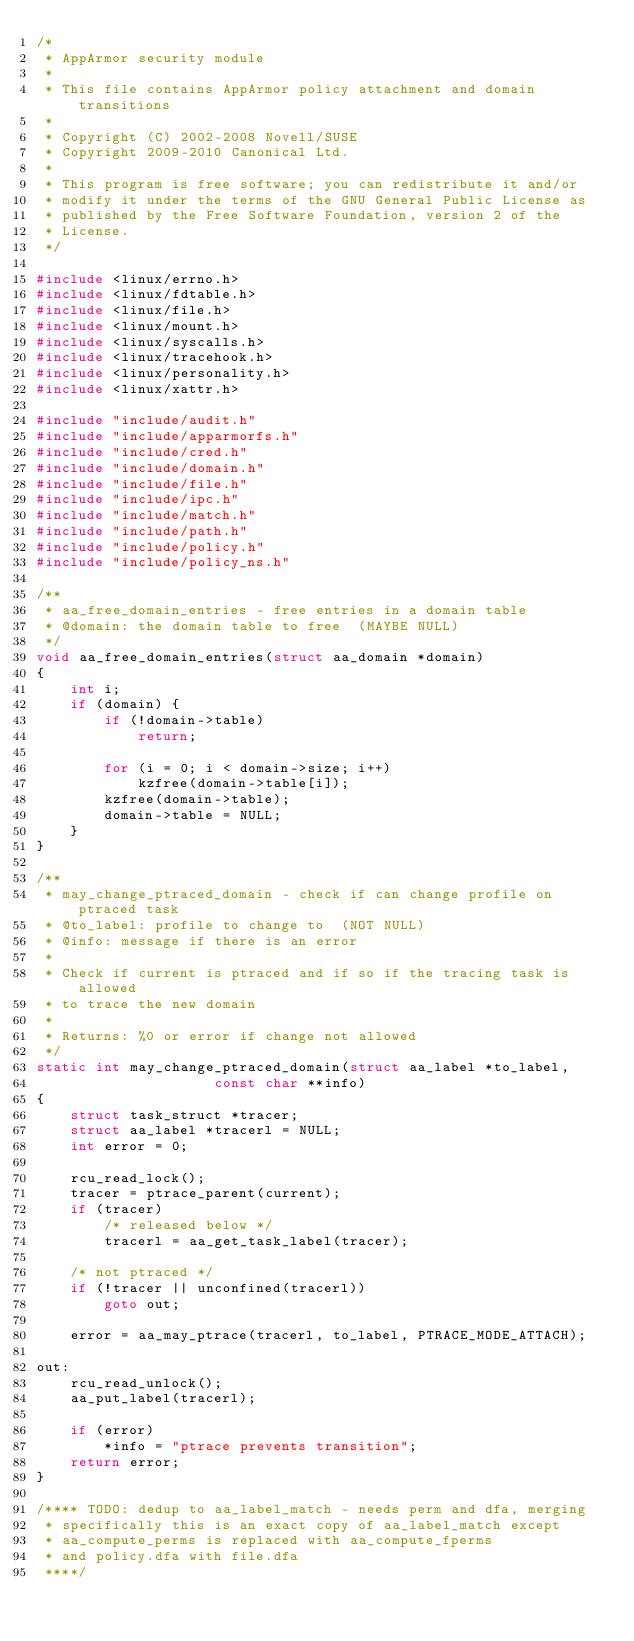<code> <loc_0><loc_0><loc_500><loc_500><_C_>/*
 * AppArmor security module
 *
 * This file contains AppArmor policy attachment and domain transitions
 *
 * Copyright (C) 2002-2008 Novell/SUSE
 * Copyright 2009-2010 Canonical Ltd.
 *
 * This program is free software; you can redistribute it and/or
 * modify it under the terms of the GNU General Public License as
 * published by the Free Software Foundation, version 2 of the
 * License.
 */

#include <linux/errno.h>
#include <linux/fdtable.h>
#include <linux/file.h>
#include <linux/mount.h>
#include <linux/syscalls.h>
#include <linux/tracehook.h>
#include <linux/personality.h>
#include <linux/xattr.h>

#include "include/audit.h"
#include "include/apparmorfs.h"
#include "include/cred.h"
#include "include/domain.h"
#include "include/file.h"
#include "include/ipc.h"
#include "include/match.h"
#include "include/path.h"
#include "include/policy.h"
#include "include/policy_ns.h"

/**
 * aa_free_domain_entries - free entries in a domain table
 * @domain: the domain table to free  (MAYBE NULL)
 */
void aa_free_domain_entries(struct aa_domain *domain)
{
	int i;
	if (domain) {
		if (!domain->table)
			return;

		for (i = 0; i < domain->size; i++)
			kzfree(domain->table[i]);
		kzfree(domain->table);
		domain->table = NULL;
	}
}

/**
 * may_change_ptraced_domain - check if can change profile on ptraced task
 * @to_label: profile to change to  (NOT NULL)
 * @info: message if there is an error
 *
 * Check if current is ptraced and if so if the tracing task is allowed
 * to trace the new domain
 *
 * Returns: %0 or error if change not allowed
 */
static int may_change_ptraced_domain(struct aa_label *to_label,
				     const char **info)
{
	struct task_struct *tracer;
	struct aa_label *tracerl = NULL;
	int error = 0;

	rcu_read_lock();
	tracer = ptrace_parent(current);
	if (tracer)
		/* released below */
		tracerl = aa_get_task_label(tracer);

	/* not ptraced */
	if (!tracer || unconfined(tracerl))
		goto out;

	error = aa_may_ptrace(tracerl, to_label, PTRACE_MODE_ATTACH);

out:
	rcu_read_unlock();
	aa_put_label(tracerl);

	if (error)
		*info = "ptrace prevents transition";
	return error;
}

/**** TODO: dedup to aa_label_match - needs perm and dfa, merging
 * specifically this is an exact copy of aa_label_match except
 * aa_compute_perms is replaced with aa_compute_fperms
 * and policy.dfa with file.dfa
 ****/</code> 